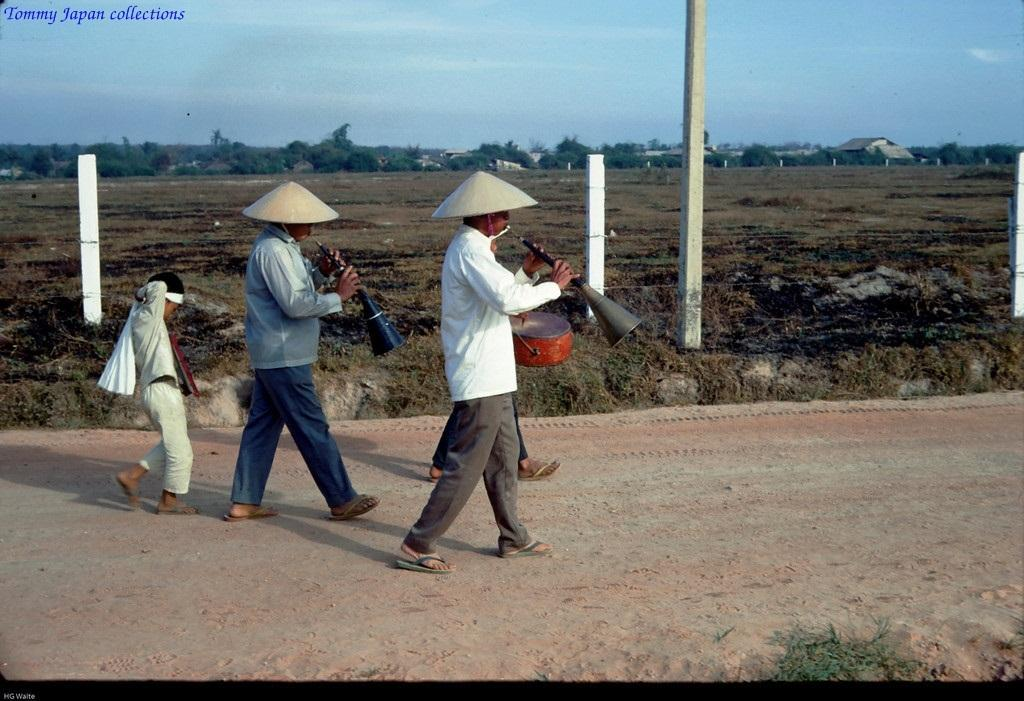What are the people in the image doing? The people in the image are walking. What are the people holding while walking? The people are holding musical instruments. What can be seen in the background of the image? There are trees, houses, and fencing visible in the background. What is the color of the sky in the image? The sky is blue and white in color. What type of sack can be seen hanging from the trees in the image? There are no sacks hanging from the trees in the image; only trees, houses, and fencing are visible in the background. What kind of celery is being used as a prop in the image? There is no celery present in the image. 